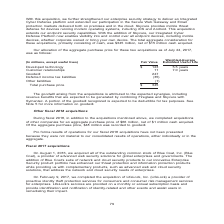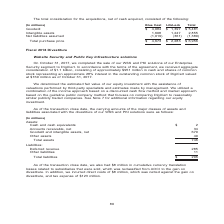According to Nortonlifelock's financial document, What was the company acquired in August 1, 2016? Blue Coat, Inc. (Blue Coat). The document states: "we acquired all of the outstanding common stock of Blue Coat, Inc. (Blue Coat), a provider of advanced web security solutions for global enterprises a..." Also, What was the company acquired in February 9, 2017? LifeLock, Inc. (LifeLock). The document states: "February 9, 2017, we completed the acquisition of LifeLock, Inc. (LifeLock) a provider of proactive identity theft protection services for consumers a..." Also, What is the total purchase price for Blue coat? According to the financial document, $4,673 (in millions). The relevant text states: "Total purchase price $ 4,673 $ 2,283 $ 6,956..." Also, can you calculate: What is the difference in Total purchase price between Blue Coat and LifeLock? Based on the calculation: 4,673-2,283, the result is 2390 (in millions). This is based on the information: "Total purchase price $ 4,673 $ 2,283 $ 6,956 Total purchase price $ 4,673 $ 2,283 $ 6,956..." The key data points involved are: 2,283, 4,673. Also, can you calculate: What is the Goodwill for Blue Coat expressed as a percentage of Total purchase price? Based on the calculation: 4,084/4,673, the result is 87.4 (percentage). This is based on the information: "Total purchase price $ 4,673 $ 2,283 $ 6,956 Goodwill $ 4,084 $ 1,397 $ 5,481 Intangible assets 1,608 1,247 2,855 Net liabilities assumed (1,019) (361) (1,380)..." The key data points involved are: 4,084, 4,673. Also, can you calculate: What is the Goodwill for LifeLock expressed as a percentage of Total purchase price? Based on the calculation: 1,397/2,283, the result is 61.19 (percentage). This is based on the information: "Goodwill $ 4,084 $ 1,397 $ 5,481 Intangible assets 1,608 1,247 2,855 Net liabilities assumed (1,019) (361) (1,380) Total purchase price $ 4,673 $ 2,283 $ 6,956..." The key data points involved are: 1,397, 2,283. 